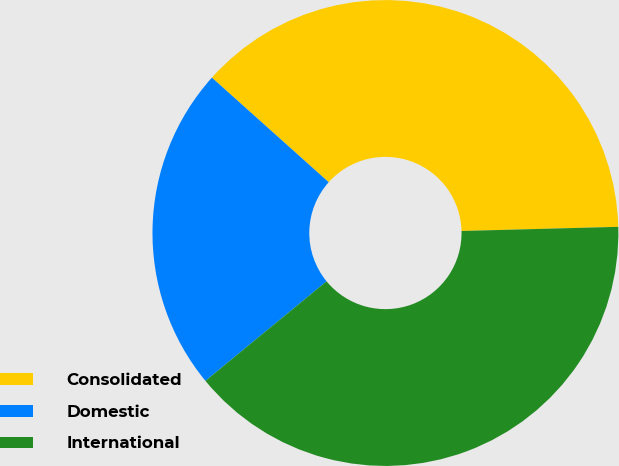Convert chart. <chart><loc_0><loc_0><loc_500><loc_500><pie_chart><fcel>Consolidated<fcel>Domestic<fcel>International<nl><fcel>37.96%<fcel>22.57%<fcel>39.48%<nl></chart> 